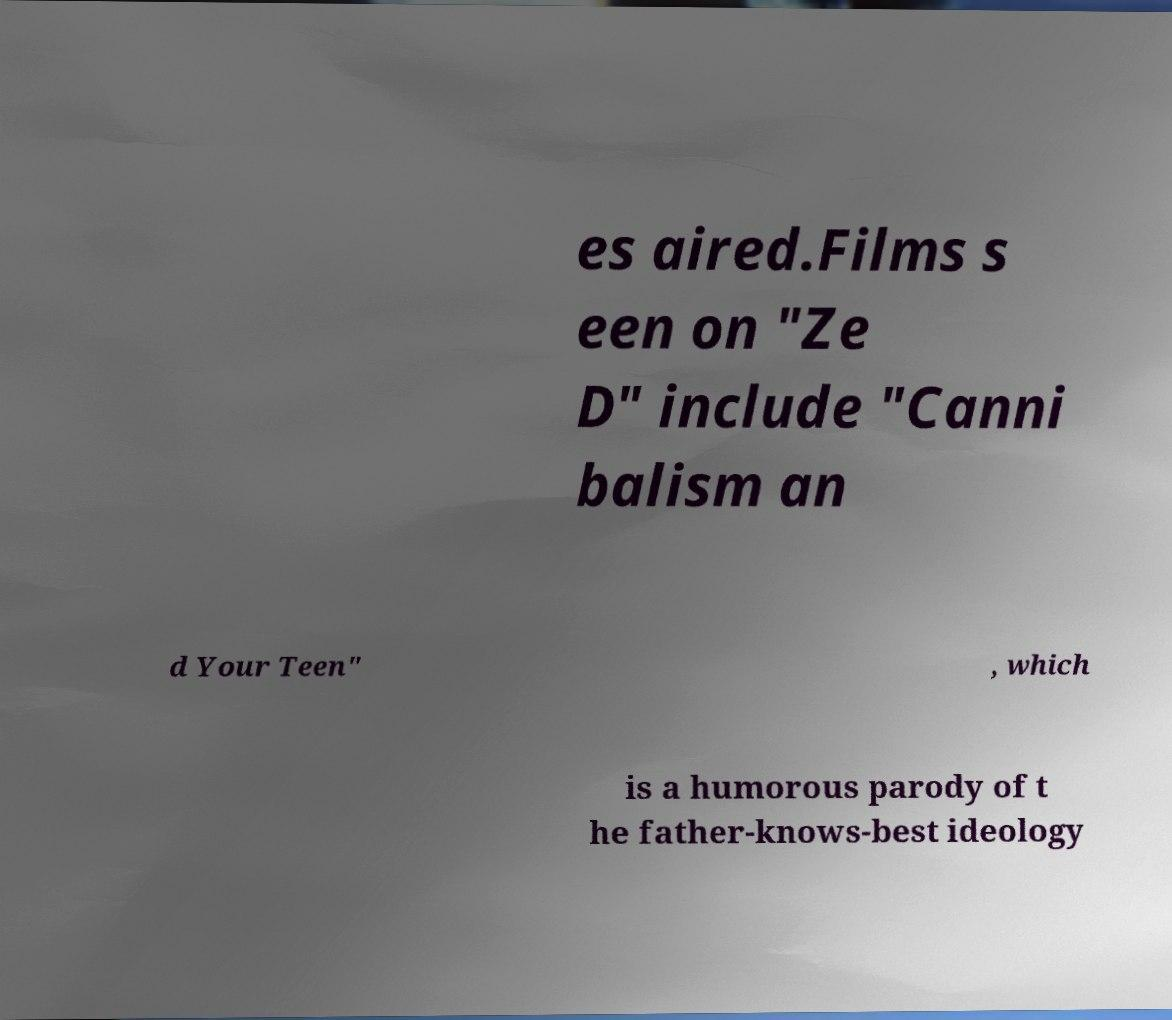There's text embedded in this image that I need extracted. Can you transcribe it verbatim? es aired.Films s een on "Ze D" include "Canni balism an d Your Teen" , which is a humorous parody of t he father-knows-best ideology 